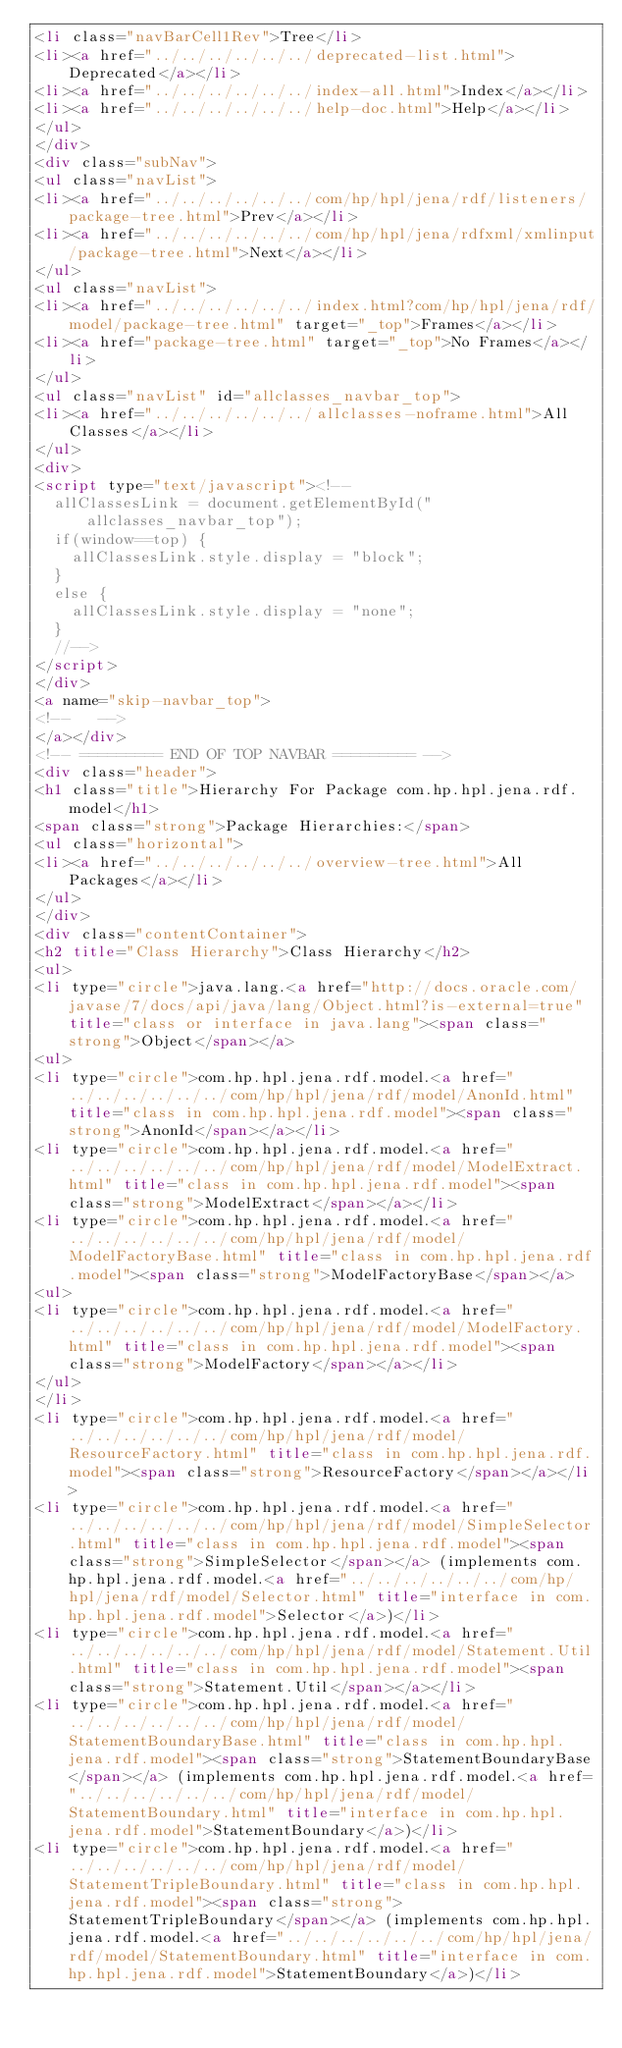<code> <loc_0><loc_0><loc_500><loc_500><_HTML_><li class="navBarCell1Rev">Tree</li>
<li><a href="../../../../../../deprecated-list.html">Deprecated</a></li>
<li><a href="../../../../../../index-all.html">Index</a></li>
<li><a href="../../../../../../help-doc.html">Help</a></li>
</ul>
</div>
<div class="subNav">
<ul class="navList">
<li><a href="../../../../../../com/hp/hpl/jena/rdf/listeners/package-tree.html">Prev</a></li>
<li><a href="../../../../../../com/hp/hpl/jena/rdfxml/xmlinput/package-tree.html">Next</a></li>
</ul>
<ul class="navList">
<li><a href="../../../../../../index.html?com/hp/hpl/jena/rdf/model/package-tree.html" target="_top">Frames</a></li>
<li><a href="package-tree.html" target="_top">No Frames</a></li>
</ul>
<ul class="navList" id="allclasses_navbar_top">
<li><a href="../../../../../../allclasses-noframe.html">All Classes</a></li>
</ul>
<div>
<script type="text/javascript"><!--
  allClassesLink = document.getElementById("allclasses_navbar_top");
  if(window==top) {
    allClassesLink.style.display = "block";
  }
  else {
    allClassesLink.style.display = "none";
  }
  //-->
</script>
</div>
<a name="skip-navbar_top">
<!--   -->
</a></div>
<!-- ========= END OF TOP NAVBAR ========= -->
<div class="header">
<h1 class="title">Hierarchy For Package com.hp.hpl.jena.rdf.model</h1>
<span class="strong">Package Hierarchies:</span>
<ul class="horizontal">
<li><a href="../../../../../../overview-tree.html">All Packages</a></li>
</ul>
</div>
<div class="contentContainer">
<h2 title="Class Hierarchy">Class Hierarchy</h2>
<ul>
<li type="circle">java.lang.<a href="http://docs.oracle.com/javase/7/docs/api/java/lang/Object.html?is-external=true" title="class or interface in java.lang"><span class="strong">Object</span></a>
<ul>
<li type="circle">com.hp.hpl.jena.rdf.model.<a href="../../../../../../com/hp/hpl/jena/rdf/model/AnonId.html" title="class in com.hp.hpl.jena.rdf.model"><span class="strong">AnonId</span></a></li>
<li type="circle">com.hp.hpl.jena.rdf.model.<a href="../../../../../../com/hp/hpl/jena/rdf/model/ModelExtract.html" title="class in com.hp.hpl.jena.rdf.model"><span class="strong">ModelExtract</span></a></li>
<li type="circle">com.hp.hpl.jena.rdf.model.<a href="../../../../../../com/hp/hpl/jena/rdf/model/ModelFactoryBase.html" title="class in com.hp.hpl.jena.rdf.model"><span class="strong">ModelFactoryBase</span></a>
<ul>
<li type="circle">com.hp.hpl.jena.rdf.model.<a href="../../../../../../com/hp/hpl/jena/rdf/model/ModelFactory.html" title="class in com.hp.hpl.jena.rdf.model"><span class="strong">ModelFactory</span></a></li>
</ul>
</li>
<li type="circle">com.hp.hpl.jena.rdf.model.<a href="../../../../../../com/hp/hpl/jena/rdf/model/ResourceFactory.html" title="class in com.hp.hpl.jena.rdf.model"><span class="strong">ResourceFactory</span></a></li>
<li type="circle">com.hp.hpl.jena.rdf.model.<a href="../../../../../../com/hp/hpl/jena/rdf/model/SimpleSelector.html" title="class in com.hp.hpl.jena.rdf.model"><span class="strong">SimpleSelector</span></a> (implements com.hp.hpl.jena.rdf.model.<a href="../../../../../../com/hp/hpl/jena/rdf/model/Selector.html" title="interface in com.hp.hpl.jena.rdf.model">Selector</a>)</li>
<li type="circle">com.hp.hpl.jena.rdf.model.<a href="../../../../../../com/hp/hpl/jena/rdf/model/Statement.Util.html" title="class in com.hp.hpl.jena.rdf.model"><span class="strong">Statement.Util</span></a></li>
<li type="circle">com.hp.hpl.jena.rdf.model.<a href="../../../../../../com/hp/hpl/jena/rdf/model/StatementBoundaryBase.html" title="class in com.hp.hpl.jena.rdf.model"><span class="strong">StatementBoundaryBase</span></a> (implements com.hp.hpl.jena.rdf.model.<a href="../../../../../../com/hp/hpl/jena/rdf/model/StatementBoundary.html" title="interface in com.hp.hpl.jena.rdf.model">StatementBoundary</a>)</li>
<li type="circle">com.hp.hpl.jena.rdf.model.<a href="../../../../../../com/hp/hpl/jena/rdf/model/StatementTripleBoundary.html" title="class in com.hp.hpl.jena.rdf.model"><span class="strong">StatementTripleBoundary</span></a> (implements com.hp.hpl.jena.rdf.model.<a href="../../../../../../com/hp/hpl/jena/rdf/model/StatementBoundary.html" title="interface in com.hp.hpl.jena.rdf.model">StatementBoundary</a>)</li></code> 